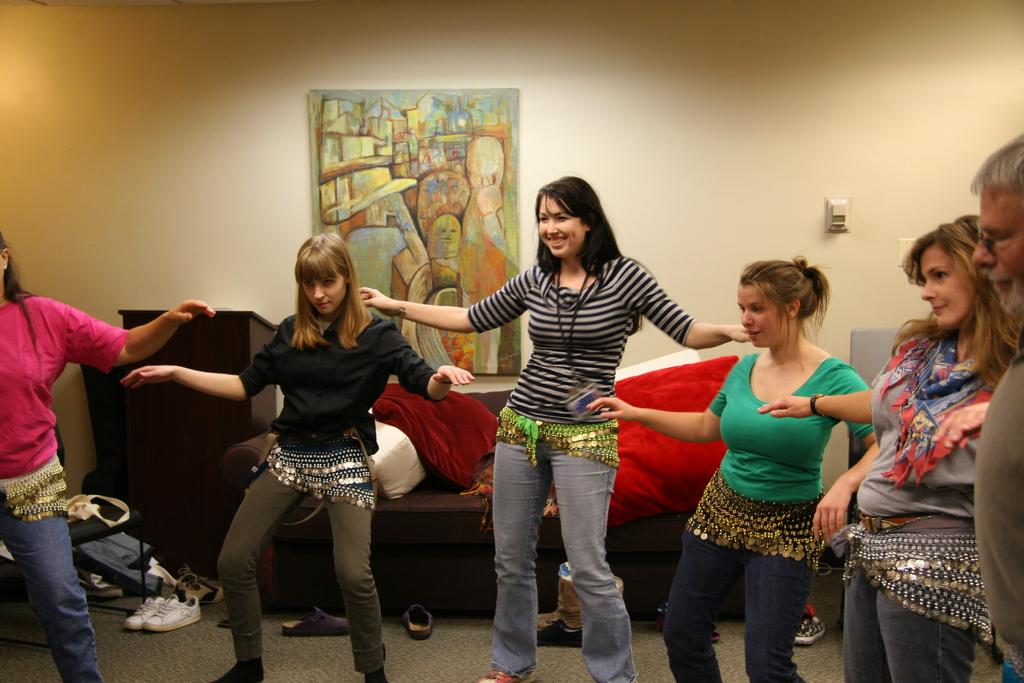What are the people in the image doing? The people in the image are dancing. What type of furniture is present in the image? There is a sofa in the image. What can be seen on the wall in the image? There is a photo frame on the wall in the image. What type of jeans is the actor wearing in the image? There is no actor or jeans present in the image. 